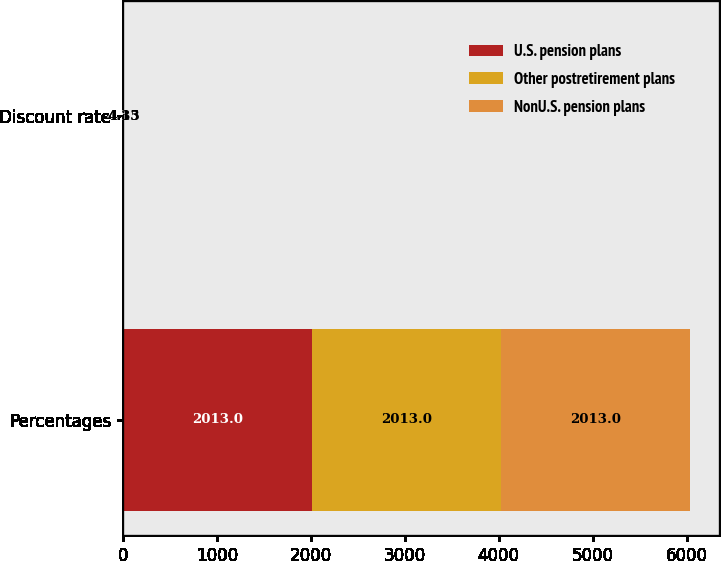Convert chart. <chart><loc_0><loc_0><loc_500><loc_500><stacked_bar_chart><ecel><fcel>Percentages<fcel>Discount rate<nl><fcel>U.S. pension plans<fcel>2013<fcel>4.51<nl><fcel>Other postretirement plans<fcel>2013<fcel>4.13<nl><fcel>NonU.S. pension plans<fcel>2013<fcel>4.35<nl></chart> 